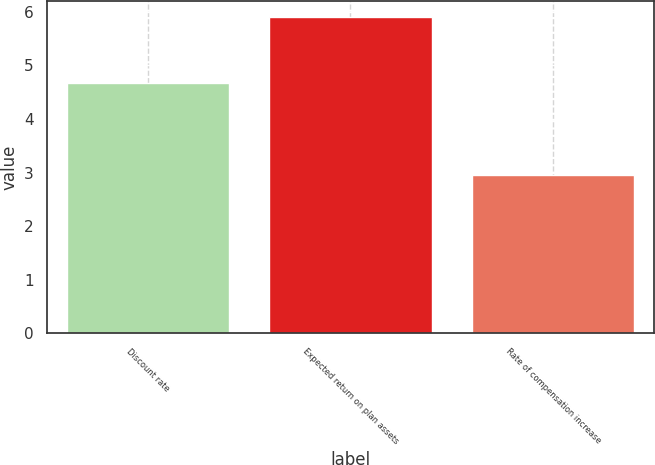Convert chart. <chart><loc_0><loc_0><loc_500><loc_500><bar_chart><fcel>Discount rate<fcel>Expected return on plan assets<fcel>Rate of compensation increase<nl><fcel>4.68<fcel>5.9<fcel>2.96<nl></chart> 